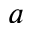Convert formula to latex. <formula><loc_0><loc_0><loc_500><loc_500>a</formula> 